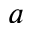Convert formula to latex. <formula><loc_0><loc_0><loc_500><loc_500>a</formula> 